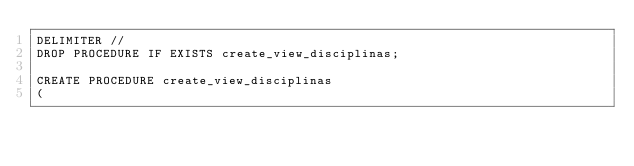Convert code to text. <code><loc_0><loc_0><loc_500><loc_500><_SQL_>DELIMITER // 
DROP PROCEDURE IF EXISTS create_view_disciplinas;

CREATE PROCEDURE create_view_disciplinas
(</code> 